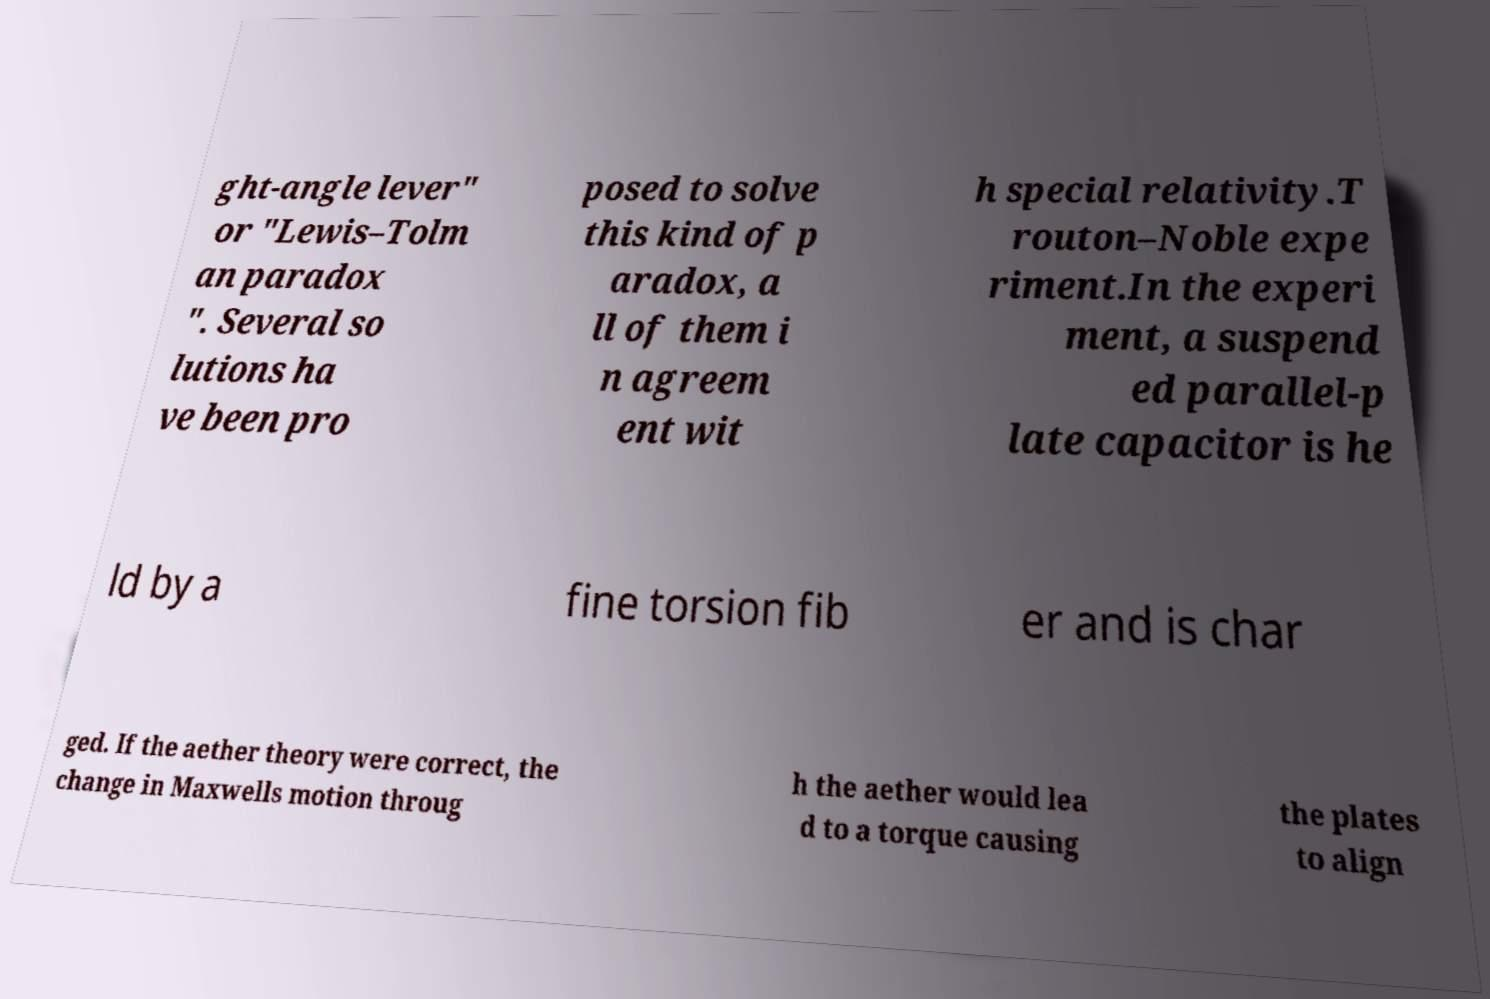Could you extract and type out the text from this image? ght-angle lever" or "Lewis–Tolm an paradox ". Several so lutions ha ve been pro posed to solve this kind of p aradox, a ll of them i n agreem ent wit h special relativity.T routon–Noble expe riment.In the experi ment, a suspend ed parallel-p late capacitor is he ld by a fine torsion fib er and is char ged. If the aether theory were correct, the change in Maxwells motion throug h the aether would lea d to a torque causing the plates to align 